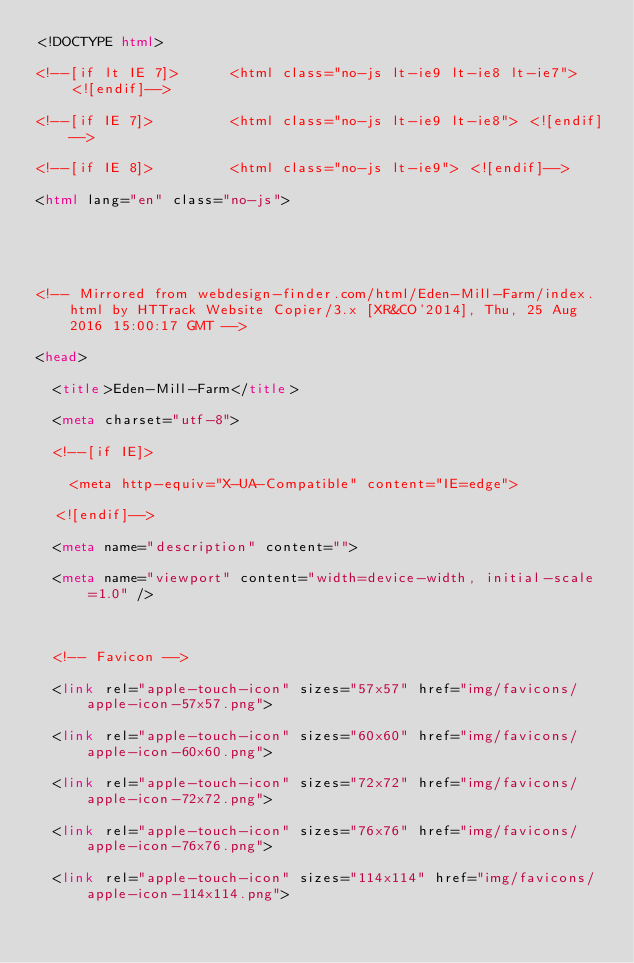<code> <loc_0><loc_0><loc_500><loc_500><_HTML_><!DOCTYPE html>
<!--[if lt IE 7]>      <html class="no-js lt-ie9 lt-ie8 lt-ie7"> <![endif]-->
<!--[if IE 7]>         <html class="no-js lt-ie9 lt-ie8"> <![endif]-->
<!--[if IE 8]>         <html class="no-js lt-ie9"> <![endif]-->
<html lang="en" class="no-js">


<!-- Mirrored from webdesign-finder.com/html/Eden-Mill-Farm/index.html by HTTrack Website Copier/3.x [XR&CO'2014], Thu, 25 Aug 2016 15:00:17 GMT -->
<head>
	<title>Eden-Mill-Farm</title>
	<meta charset="utf-8">
	<!--[if IE]>
    <meta http-equiv="X-UA-Compatible" content="IE=edge">
  <![endif]-->
	<meta name="description" content="">
	<meta name="viewport" content="width=device-width, initial-scale=1.0" />

	<!-- Favicon -->
	<link rel="apple-touch-icon" sizes="57x57" href="img/favicons/apple-icon-57x57.png">
	<link rel="apple-touch-icon" sizes="60x60" href="img/favicons/apple-icon-60x60.png">
	<link rel="apple-touch-icon" sizes="72x72" href="img/favicons/apple-icon-72x72.png">
	<link rel="apple-touch-icon" sizes="76x76" href="img/favicons/apple-icon-76x76.png">
	<link rel="apple-touch-icon" sizes="114x114" href="img/favicons/apple-icon-114x114.png"></code> 